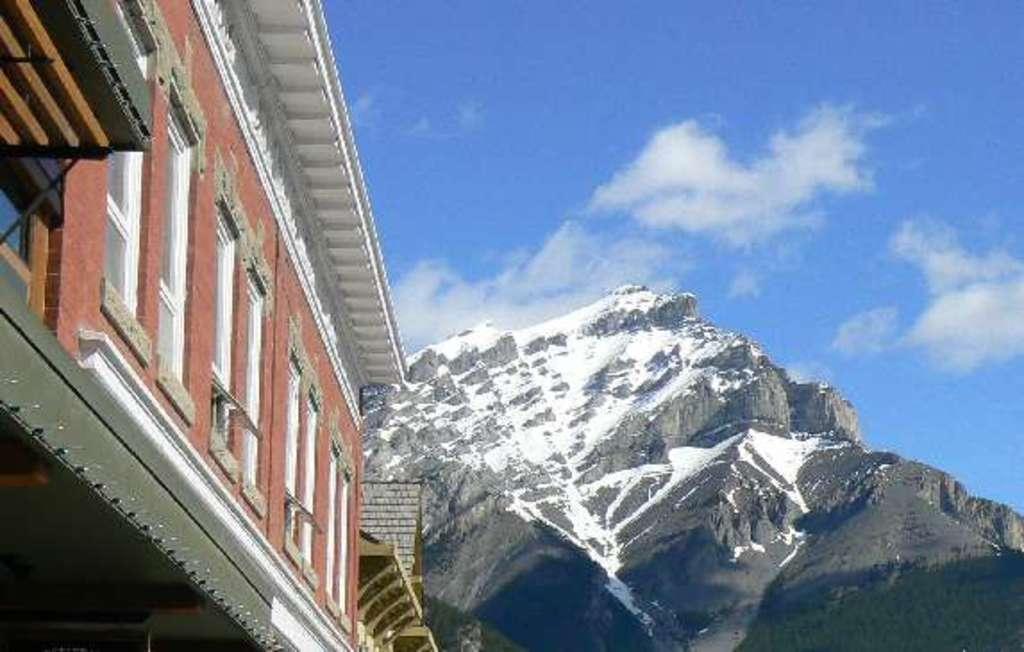Please provide a concise description of this image. In this image we can see a building with windows and a rock, in the background, we can see the sky with clouds. 